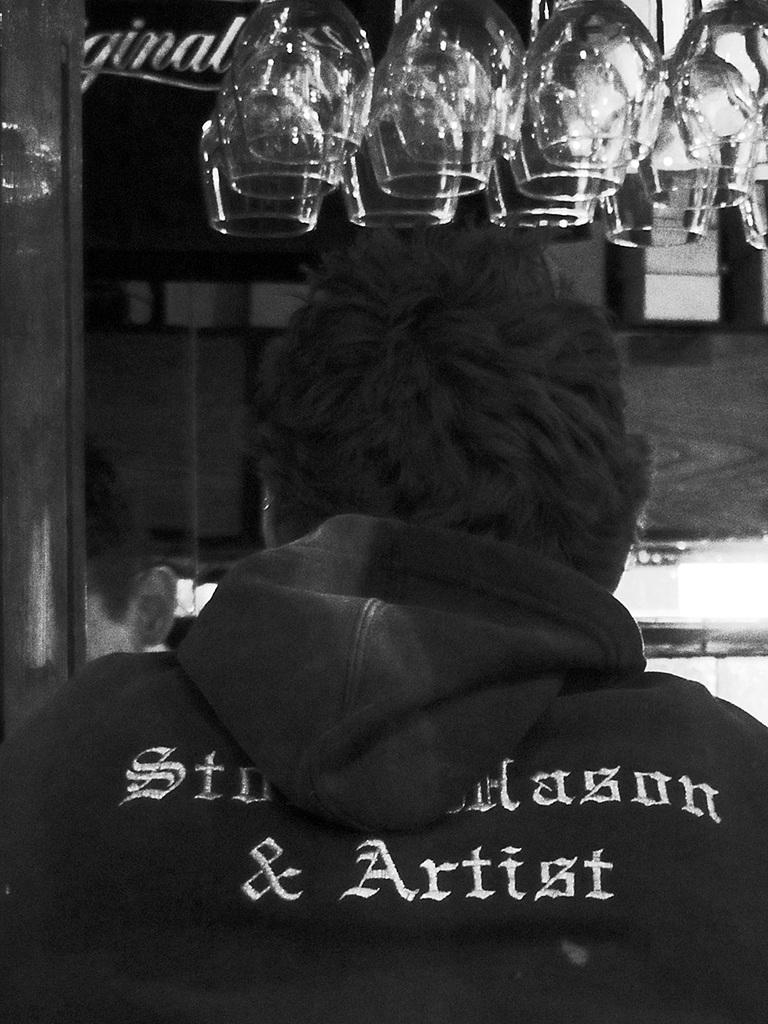What is the main subject of the image? There is a person in the image. What can be seen in the background of the image? The background of the image includes glasses. What is the color scheme of the image? The image is in black and white. What type of rock is being used as a tray by the person in the image? There is no rock or tray present in the image; it features a person and glasses in the background. 